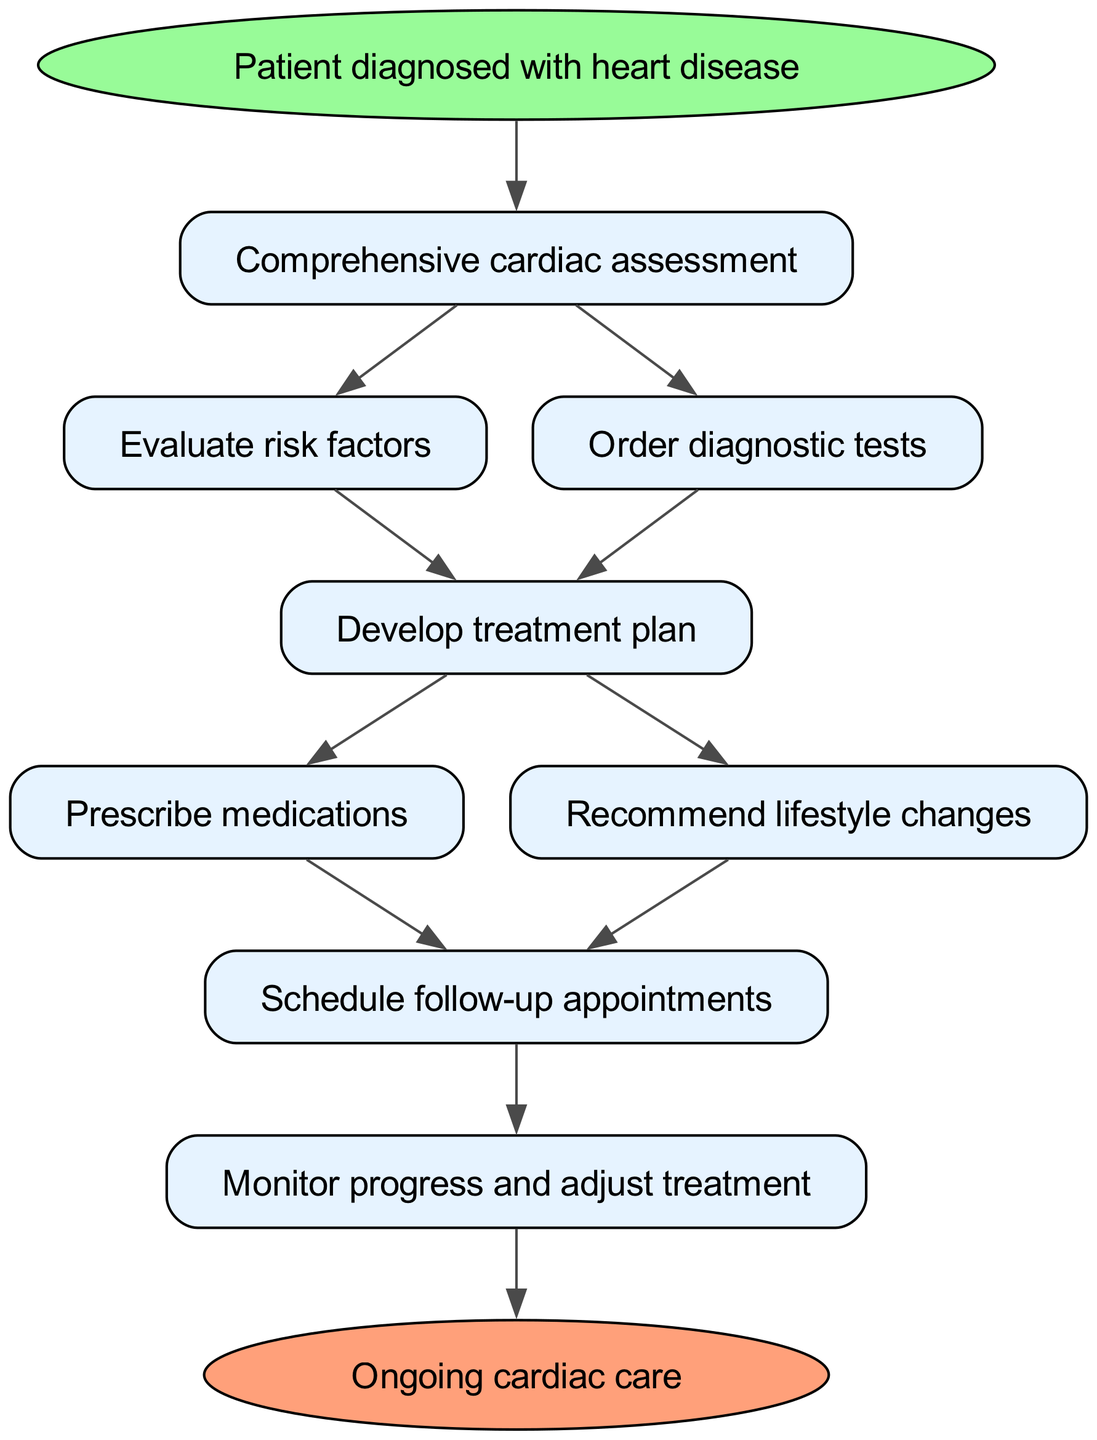What is the first step after a patient is diagnosed with heart disease? The diagram shows that the first step following a patient being diagnosed with heart disease is a "Comprehensive cardiac assessment". This node directly follows "Patient diagnosed with heart disease".
Answer: Comprehensive cardiac assessment How many total nodes are in the flow chart? To determine the total number of nodes, I count all the unique elements represented in the diagram, which includes the start and end nodes along with the steps in between. There are 10 nodes in total.
Answer: 10 What action occurs after the "Evaluate risk factors"? The diagram indicates that after "Evaluate risk factors", the next step is to "Develop treatment plan". This is evidenced by the connection from the risk node to the plan node.
Answer: Develop treatment plan Which two nodes lead into "Schedule follow-up appointments"? The diagram clearly shows that both "Prescribe medications" and "Recommend lifestyle changes" lead into "Schedule follow-up appointments", as represented by the directed edges connecting to this node.
Answer: Prescribe medications, Recommend lifestyle changes What is the last node in the flow chart? The final node in the diagram is "Ongoing cardiac care", which is clearly marked as the endpoint after the "Monitor progress and adjust treatment" step, following a series of previous nodes.
Answer: Ongoing cardiac care Which nodes are directly connected to the "Develop treatment plan"? According to the diagram, "Develop treatment plan" receives input from two nodes: "Evaluate risk factors" and "Order diagnostic tests". Both these nodes connect to the plan node.
Answer: Evaluate risk factors, Order diagnostic tests What is the overall purpose of this flow chart? The purpose of this flow chart is to outline the process of patient assessment and treatment planning for newly diagnosed heart disease, integrating various steps from diagnosis to ongoing care. This can be deduced from tracing the flow from the start node to the end node.
Answer: Patient assessment and treatment planning How many edges are in the flow chart? To find the total number of edges, I count all the directed connections between the nodes. There are a total of 10 edges that connect the various nodes throughout the flow chart.
Answer: 10 